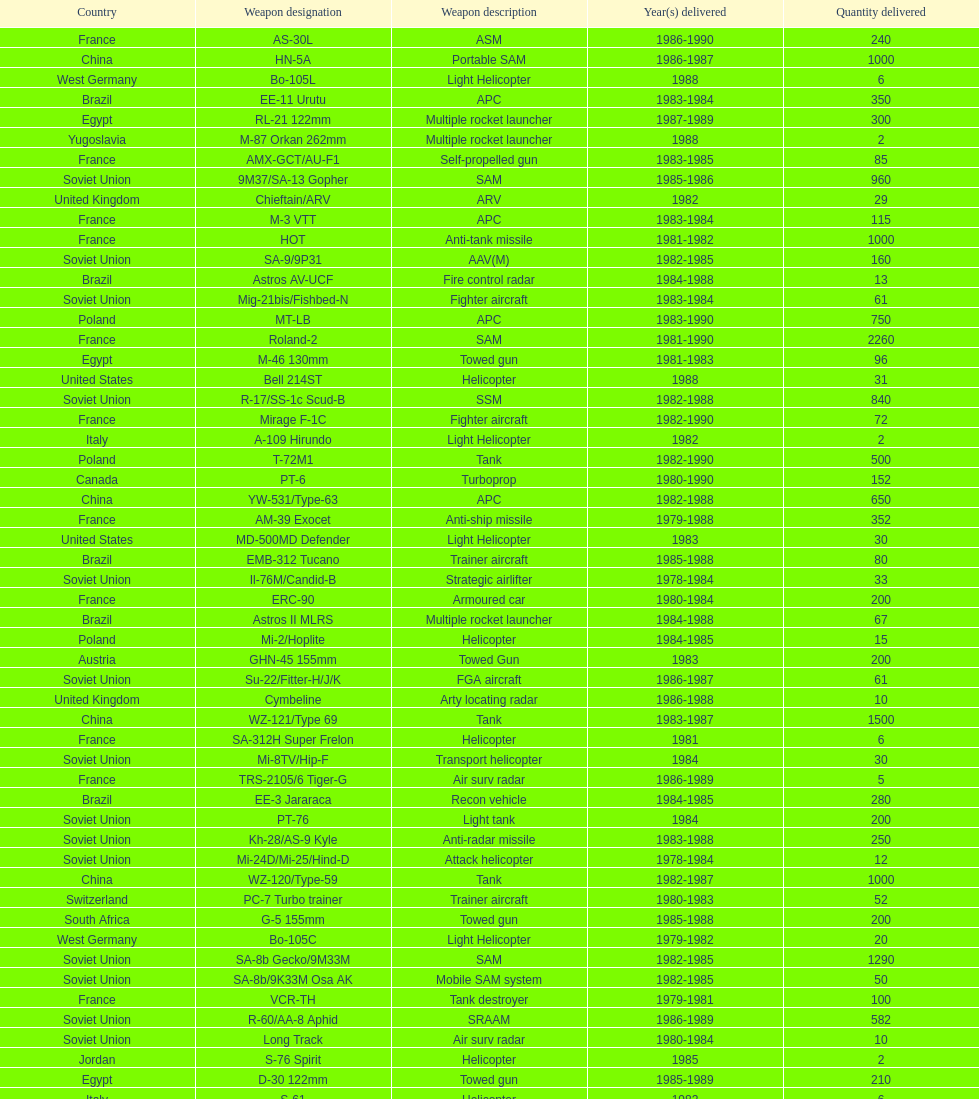According to this list, how many countries sold weapons to iraq? 21. 